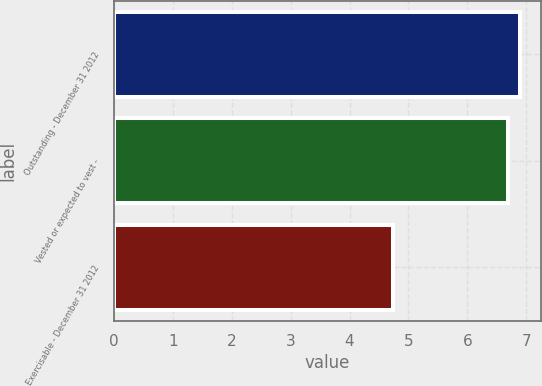Convert chart to OTSL. <chart><loc_0><loc_0><loc_500><loc_500><bar_chart><fcel>Outstanding - December 31 2012<fcel>Vested or expected to vest -<fcel>Exercisable - December 31 2012<nl><fcel>6.9<fcel>6.69<fcel>4.73<nl></chart> 